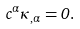<formula> <loc_0><loc_0><loc_500><loc_500>c ^ { \alpha } \kappa _ { , \alpha } = 0 .</formula> 